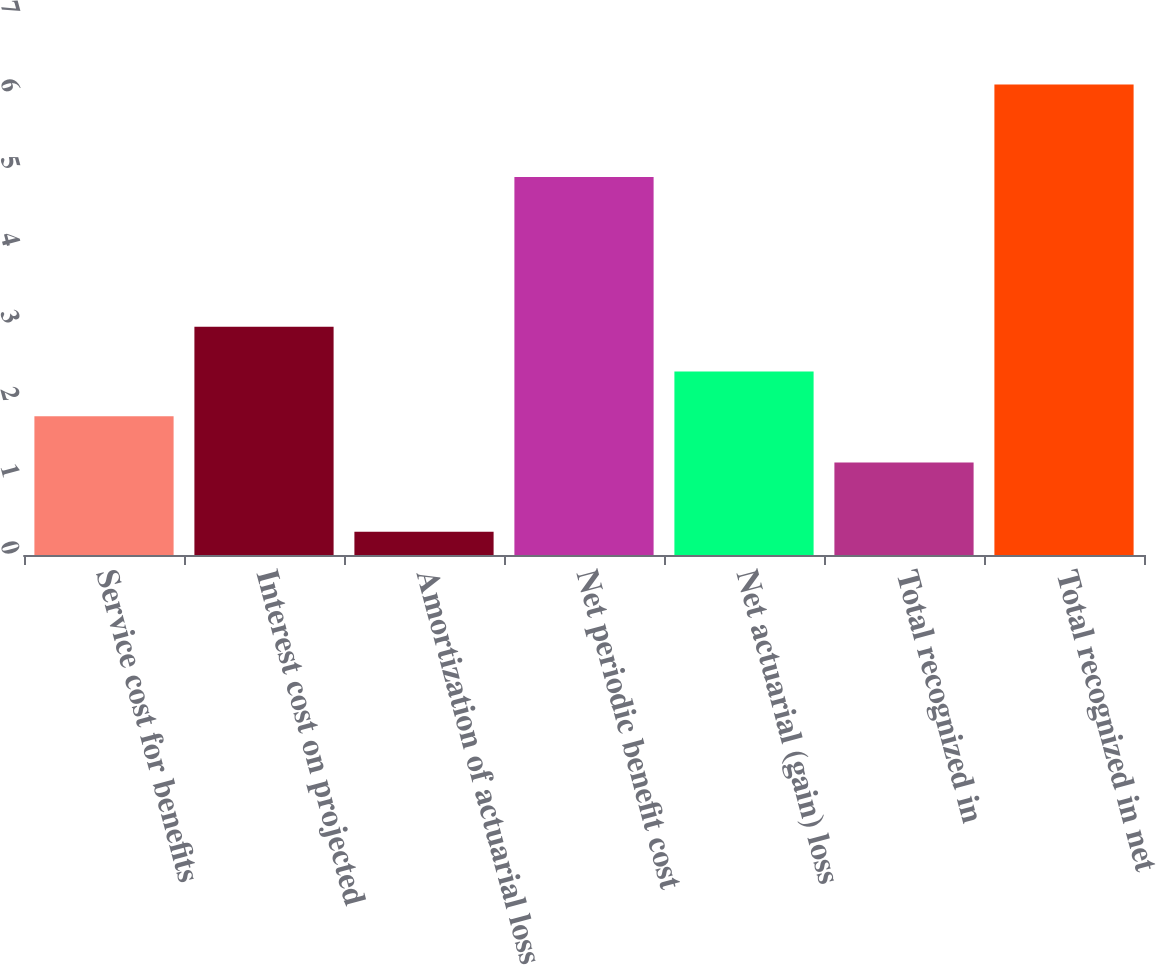Convert chart to OTSL. <chart><loc_0><loc_0><loc_500><loc_500><bar_chart><fcel>Service cost for benefits<fcel>Interest cost on projected<fcel>Amortization of actuarial loss<fcel>Net periodic benefit cost<fcel>Net actuarial (gain) loss<fcel>Total recognized in<fcel>Total recognized in net<nl><fcel>1.8<fcel>2.96<fcel>0.3<fcel>4.9<fcel>2.38<fcel>1.2<fcel>6.1<nl></chart> 